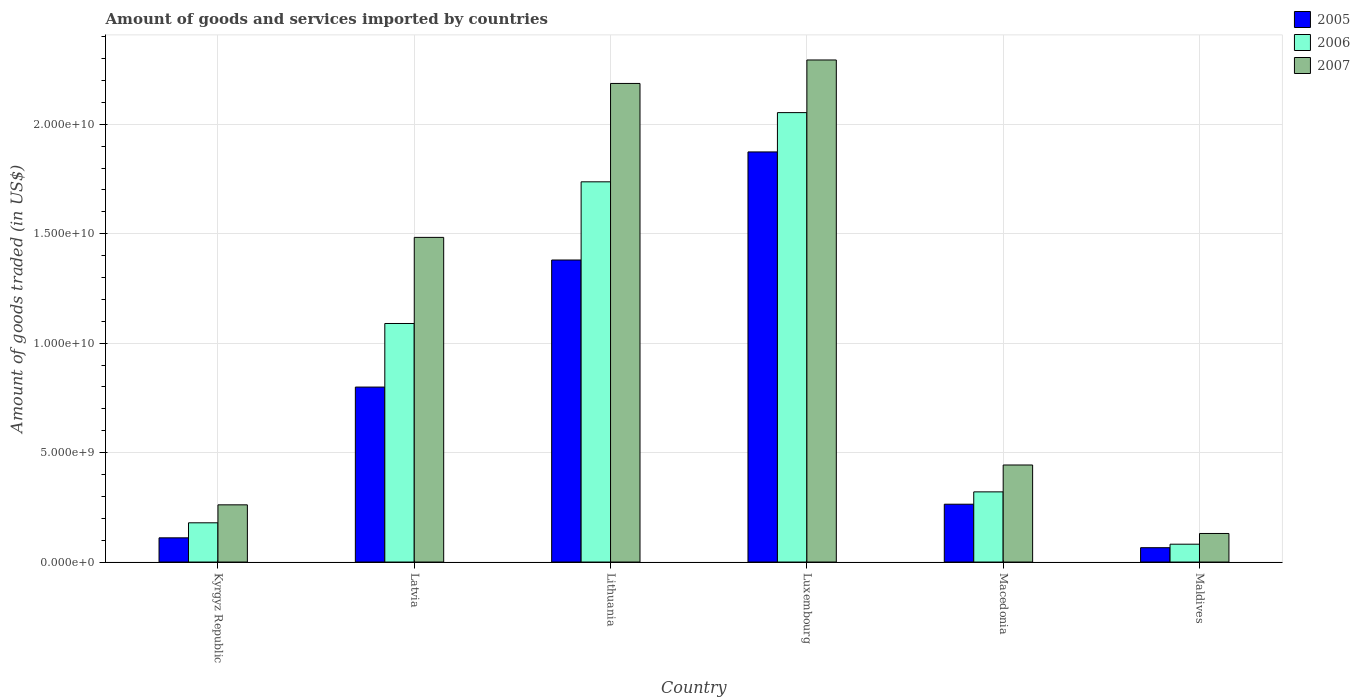How many different coloured bars are there?
Provide a succinct answer. 3. How many groups of bars are there?
Ensure brevity in your answer.  6. Are the number of bars per tick equal to the number of legend labels?
Offer a terse response. Yes. How many bars are there on the 5th tick from the right?
Provide a succinct answer. 3. What is the label of the 3rd group of bars from the left?
Make the answer very short. Lithuania. In how many cases, is the number of bars for a given country not equal to the number of legend labels?
Make the answer very short. 0. What is the total amount of goods and services imported in 2006 in Kyrgyz Republic?
Your answer should be very brief. 1.79e+09. Across all countries, what is the maximum total amount of goods and services imported in 2007?
Keep it short and to the point. 2.29e+1. Across all countries, what is the minimum total amount of goods and services imported in 2006?
Your answer should be compact. 8.15e+08. In which country was the total amount of goods and services imported in 2005 maximum?
Make the answer very short. Luxembourg. In which country was the total amount of goods and services imported in 2006 minimum?
Give a very brief answer. Maldives. What is the total total amount of goods and services imported in 2006 in the graph?
Offer a very short reply. 5.46e+1. What is the difference between the total amount of goods and services imported in 2006 in Macedonia and that in Maldives?
Your response must be concise. 2.39e+09. What is the difference between the total amount of goods and services imported in 2005 in Latvia and the total amount of goods and services imported in 2006 in Macedonia?
Provide a succinct answer. 4.79e+09. What is the average total amount of goods and services imported in 2007 per country?
Your response must be concise. 1.13e+1. What is the difference between the total amount of goods and services imported of/in 2006 and total amount of goods and services imported of/in 2007 in Kyrgyz Republic?
Provide a succinct answer. -8.21e+08. What is the ratio of the total amount of goods and services imported in 2006 in Latvia to that in Luxembourg?
Your answer should be compact. 0.53. What is the difference between the highest and the second highest total amount of goods and services imported in 2006?
Provide a short and direct response. 6.47e+09. What is the difference between the highest and the lowest total amount of goods and services imported in 2007?
Keep it short and to the point. 2.16e+1. In how many countries, is the total amount of goods and services imported in 2006 greater than the average total amount of goods and services imported in 2006 taken over all countries?
Your answer should be compact. 3. Is the sum of the total amount of goods and services imported in 2007 in Kyrgyz Republic and Latvia greater than the maximum total amount of goods and services imported in 2006 across all countries?
Provide a succinct answer. No. Is it the case that in every country, the sum of the total amount of goods and services imported in 2007 and total amount of goods and services imported in 2006 is greater than the total amount of goods and services imported in 2005?
Provide a succinct answer. Yes. How many bars are there?
Make the answer very short. 18. Are all the bars in the graph horizontal?
Provide a short and direct response. No. What is the difference between two consecutive major ticks on the Y-axis?
Provide a succinct answer. 5.00e+09. Are the values on the major ticks of Y-axis written in scientific E-notation?
Offer a terse response. Yes. Where does the legend appear in the graph?
Give a very brief answer. Top right. How many legend labels are there?
Provide a succinct answer. 3. How are the legend labels stacked?
Ensure brevity in your answer.  Vertical. What is the title of the graph?
Make the answer very short. Amount of goods and services imported by countries. Does "1976" appear as one of the legend labels in the graph?
Make the answer very short. No. What is the label or title of the Y-axis?
Your answer should be compact. Amount of goods traded (in US$). What is the Amount of goods traded (in US$) of 2005 in Kyrgyz Republic?
Your response must be concise. 1.11e+09. What is the Amount of goods traded (in US$) of 2006 in Kyrgyz Republic?
Provide a succinct answer. 1.79e+09. What is the Amount of goods traded (in US$) of 2007 in Kyrgyz Republic?
Offer a very short reply. 2.61e+09. What is the Amount of goods traded (in US$) of 2005 in Latvia?
Offer a terse response. 7.99e+09. What is the Amount of goods traded (in US$) of 2006 in Latvia?
Provide a succinct answer. 1.09e+1. What is the Amount of goods traded (in US$) of 2007 in Latvia?
Ensure brevity in your answer.  1.48e+1. What is the Amount of goods traded (in US$) of 2005 in Lithuania?
Offer a very short reply. 1.38e+1. What is the Amount of goods traded (in US$) in 2006 in Lithuania?
Provide a short and direct response. 1.74e+1. What is the Amount of goods traded (in US$) of 2007 in Lithuania?
Provide a succinct answer. 2.19e+1. What is the Amount of goods traded (in US$) in 2005 in Luxembourg?
Offer a terse response. 1.87e+1. What is the Amount of goods traded (in US$) of 2006 in Luxembourg?
Offer a terse response. 2.05e+1. What is the Amount of goods traded (in US$) of 2007 in Luxembourg?
Make the answer very short. 2.29e+1. What is the Amount of goods traded (in US$) in 2005 in Macedonia?
Your answer should be compact. 2.64e+09. What is the Amount of goods traded (in US$) in 2006 in Macedonia?
Ensure brevity in your answer.  3.21e+09. What is the Amount of goods traded (in US$) in 2007 in Macedonia?
Offer a terse response. 4.43e+09. What is the Amount of goods traded (in US$) in 2005 in Maldives?
Give a very brief answer. 6.55e+08. What is the Amount of goods traded (in US$) in 2006 in Maldives?
Keep it short and to the point. 8.15e+08. What is the Amount of goods traded (in US$) in 2007 in Maldives?
Your answer should be very brief. 1.30e+09. Across all countries, what is the maximum Amount of goods traded (in US$) in 2005?
Provide a short and direct response. 1.87e+1. Across all countries, what is the maximum Amount of goods traded (in US$) in 2006?
Your answer should be compact. 2.05e+1. Across all countries, what is the maximum Amount of goods traded (in US$) in 2007?
Provide a short and direct response. 2.29e+1. Across all countries, what is the minimum Amount of goods traded (in US$) of 2005?
Keep it short and to the point. 6.55e+08. Across all countries, what is the minimum Amount of goods traded (in US$) of 2006?
Give a very brief answer. 8.15e+08. Across all countries, what is the minimum Amount of goods traded (in US$) in 2007?
Provide a succinct answer. 1.30e+09. What is the total Amount of goods traded (in US$) in 2005 in the graph?
Provide a short and direct response. 4.49e+1. What is the total Amount of goods traded (in US$) in 2006 in the graph?
Your response must be concise. 5.46e+1. What is the total Amount of goods traded (in US$) of 2007 in the graph?
Your answer should be very brief. 6.80e+1. What is the difference between the Amount of goods traded (in US$) in 2005 in Kyrgyz Republic and that in Latvia?
Your answer should be very brief. -6.89e+09. What is the difference between the Amount of goods traded (in US$) in 2006 in Kyrgyz Republic and that in Latvia?
Your response must be concise. -9.11e+09. What is the difference between the Amount of goods traded (in US$) in 2007 in Kyrgyz Republic and that in Latvia?
Give a very brief answer. -1.22e+1. What is the difference between the Amount of goods traded (in US$) in 2005 in Kyrgyz Republic and that in Lithuania?
Provide a succinct answer. -1.27e+1. What is the difference between the Amount of goods traded (in US$) in 2006 in Kyrgyz Republic and that in Lithuania?
Keep it short and to the point. -1.56e+1. What is the difference between the Amount of goods traded (in US$) in 2007 in Kyrgyz Republic and that in Lithuania?
Your answer should be compact. -1.93e+1. What is the difference between the Amount of goods traded (in US$) of 2005 in Kyrgyz Republic and that in Luxembourg?
Your response must be concise. -1.76e+1. What is the difference between the Amount of goods traded (in US$) in 2006 in Kyrgyz Republic and that in Luxembourg?
Your response must be concise. -1.87e+1. What is the difference between the Amount of goods traded (in US$) of 2007 in Kyrgyz Republic and that in Luxembourg?
Make the answer very short. -2.03e+1. What is the difference between the Amount of goods traded (in US$) of 2005 in Kyrgyz Republic and that in Macedonia?
Ensure brevity in your answer.  -1.54e+09. What is the difference between the Amount of goods traded (in US$) in 2006 in Kyrgyz Republic and that in Macedonia?
Your answer should be very brief. -1.41e+09. What is the difference between the Amount of goods traded (in US$) of 2007 in Kyrgyz Republic and that in Macedonia?
Your response must be concise. -1.82e+09. What is the difference between the Amount of goods traded (in US$) of 2005 in Kyrgyz Republic and that in Maldives?
Keep it short and to the point. 4.50e+08. What is the difference between the Amount of goods traded (in US$) of 2006 in Kyrgyz Republic and that in Maldives?
Provide a short and direct response. 9.77e+08. What is the difference between the Amount of goods traded (in US$) of 2007 in Kyrgyz Republic and that in Maldives?
Give a very brief answer. 1.31e+09. What is the difference between the Amount of goods traded (in US$) in 2005 in Latvia and that in Lithuania?
Provide a short and direct response. -5.81e+09. What is the difference between the Amount of goods traded (in US$) of 2006 in Latvia and that in Lithuania?
Offer a very short reply. -6.47e+09. What is the difference between the Amount of goods traded (in US$) of 2007 in Latvia and that in Lithuania?
Give a very brief answer. -7.03e+09. What is the difference between the Amount of goods traded (in US$) in 2005 in Latvia and that in Luxembourg?
Offer a very short reply. -1.07e+1. What is the difference between the Amount of goods traded (in US$) of 2006 in Latvia and that in Luxembourg?
Give a very brief answer. -9.64e+09. What is the difference between the Amount of goods traded (in US$) in 2007 in Latvia and that in Luxembourg?
Ensure brevity in your answer.  -8.11e+09. What is the difference between the Amount of goods traded (in US$) of 2005 in Latvia and that in Macedonia?
Offer a very short reply. 5.35e+09. What is the difference between the Amount of goods traded (in US$) in 2006 in Latvia and that in Macedonia?
Keep it short and to the point. 7.69e+09. What is the difference between the Amount of goods traded (in US$) of 2007 in Latvia and that in Macedonia?
Your answer should be compact. 1.04e+1. What is the difference between the Amount of goods traded (in US$) in 2005 in Latvia and that in Maldives?
Offer a terse response. 7.34e+09. What is the difference between the Amount of goods traded (in US$) of 2006 in Latvia and that in Maldives?
Give a very brief answer. 1.01e+1. What is the difference between the Amount of goods traded (in US$) of 2007 in Latvia and that in Maldives?
Provide a short and direct response. 1.35e+1. What is the difference between the Amount of goods traded (in US$) of 2005 in Lithuania and that in Luxembourg?
Your answer should be very brief. -4.94e+09. What is the difference between the Amount of goods traded (in US$) of 2006 in Lithuania and that in Luxembourg?
Keep it short and to the point. -3.16e+09. What is the difference between the Amount of goods traded (in US$) of 2007 in Lithuania and that in Luxembourg?
Your answer should be compact. -1.07e+09. What is the difference between the Amount of goods traded (in US$) in 2005 in Lithuania and that in Macedonia?
Offer a terse response. 1.12e+1. What is the difference between the Amount of goods traded (in US$) of 2006 in Lithuania and that in Macedonia?
Provide a succinct answer. 1.42e+1. What is the difference between the Amount of goods traded (in US$) in 2007 in Lithuania and that in Macedonia?
Your response must be concise. 1.74e+1. What is the difference between the Amount of goods traded (in US$) of 2005 in Lithuania and that in Maldives?
Your answer should be very brief. 1.31e+1. What is the difference between the Amount of goods traded (in US$) of 2006 in Lithuania and that in Maldives?
Offer a terse response. 1.66e+1. What is the difference between the Amount of goods traded (in US$) in 2007 in Lithuania and that in Maldives?
Offer a very short reply. 2.06e+1. What is the difference between the Amount of goods traded (in US$) of 2005 in Luxembourg and that in Macedonia?
Make the answer very short. 1.61e+1. What is the difference between the Amount of goods traded (in US$) in 2006 in Luxembourg and that in Macedonia?
Keep it short and to the point. 1.73e+1. What is the difference between the Amount of goods traded (in US$) in 2007 in Luxembourg and that in Macedonia?
Provide a short and direct response. 1.85e+1. What is the difference between the Amount of goods traded (in US$) of 2005 in Luxembourg and that in Maldives?
Offer a very short reply. 1.81e+1. What is the difference between the Amount of goods traded (in US$) of 2006 in Luxembourg and that in Maldives?
Your answer should be compact. 1.97e+1. What is the difference between the Amount of goods traded (in US$) of 2007 in Luxembourg and that in Maldives?
Ensure brevity in your answer.  2.16e+1. What is the difference between the Amount of goods traded (in US$) in 2005 in Macedonia and that in Maldives?
Make the answer very short. 1.99e+09. What is the difference between the Amount of goods traded (in US$) of 2006 in Macedonia and that in Maldives?
Offer a terse response. 2.39e+09. What is the difference between the Amount of goods traded (in US$) of 2007 in Macedonia and that in Maldives?
Ensure brevity in your answer.  3.13e+09. What is the difference between the Amount of goods traded (in US$) of 2005 in Kyrgyz Republic and the Amount of goods traded (in US$) of 2006 in Latvia?
Your answer should be compact. -9.79e+09. What is the difference between the Amount of goods traded (in US$) in 2005 in Kyrgyz Republic and the Amount of goods traded (in US$) in 2007 in Latvia?
Make the answer very short. -1.37e+1. What is the difference between the Amount of goods traded (in US$) of 2006 in Kyrgyz Republic and the Amount of goods traded (in US$) of 2007 in Latvia?
Give a very brief answer. -1.30e+1. What is the difference between the Amount of goods traded (in US$) in 2005 in Kyrgyz Republic and the Amount of goods traded (in US$) in 2006 in Lithuania?
Provide a succinct answer. -1.63e+1. What is the difference between the Amount of goods traded (in US$) of 2005 in Kyrgyz Republic and the Amount of goods traded (in US$) of 2007 in Lithuania?
Ensure brevity in your answer.  -2.08e+1. What is the difference between the Amount of goods traded (in US$) in 2006 in Kyrgyz Republic and the Amount of goods traded (in US$) in 2007 in Lithuania?
Offer a very short reply. -2.01e+1. What is the difference between the Amount of goods traded (in US$) of 2005 in Kyrgyz Republic and the Amount of goods traded (in US$) of 2006 in Luxembourg?
Keep it short and to the point. -1.94e+1. What is the difference between the Amount of goods traded (in US$) in 2005 in Kyrgyz Republic and the Amount of goods traded (in US$) in 2007 in Luxembourg?
Keep it short and to the point. -2.18e+1. What is the difference between the Amount of goods traded (in US$) of 2006 in Kyrgyz Republic and the Amount of goods traded (in US$) of 2007 in Luxembourg?
Your response must be concise. -2.11e+1. What is the difference between the Amount of goods traded (in US$) of 2005 in Kyrgyz Republic and the Amount of goods traded (in US$) of 2006 in Macedonia?
Your answer should be very brief. -2.10e+09. What is the difference between the Amount of goods traded (in US$) of 2005 in Kyrgyz Republic and the Amount of goods traded (in US$) of 2007 in Macedonia?
Your answer should be compact. -3.33e+09. What is the difference between the Amount of goods traded (in US$) in 2006 in Kyrgyz Republic and the Amount of goods traded (in US$) in 2007 in Macedonia?
Give a very brief answer. -2.64e+09. What is the difference between the Amount of goods traded (in US$) of 2005 in Kyrgyz Republic and the Amount of goods traded (in US$) of 2006 in Maldives?
Provide a succinct answer. 2.90e+08. What is the difference between the Amount of goods traded (in US$) of 2005 in Kyrgyz Republic and the Amount of goods traded (in US$) of 2007 in Maldives?
Your answer should be very brief. -1.99e+08. What is the difference between the Amount of goods traded (in US$) of 2006 in Kyrgyz Republic and the Amount of goods traded (in US$) of 2007 in Maldives?
Your answer should be compact. 4.88e+08. What is the difference between the Amount of goods traded (in US$) in 2005 in Latvia and the Amount of goods traded (in US$) in 2006 in Lithuania?
Offer a terse response. -9.38e+09. What is the difference between the Amount of goods traded (in US$) in 2005 in Latvia and the Amount of goods traded (in US$) in 2007 in Lithuania?
Offer a very short reply. -1.39e+1. What is the difference between the Amount of goods traded (in US$) in 2006 in Latvia and the Amount of goods traded (in US$) in 2007 in Lithuania?
Offer a terse response. -1.10e+1. What is the difference between the Amount of goods traded (in US$) in 2005 in Latvia and the Amount of goods traded (in US$) in 2006 in Luxembourg?
Ensure brevity in your answer.  -1.25e+1. What is the difference between the Amount of goods traded (in US$) in 2005 in Latvia and the Amount of goods traded (in US$) in 2007 in Luxembourg?
Make the answer very short. -1.49e+1. What is the difference between the Amount of goods traded (in US$) in 2006 in Latvia and the Amount of goods traded (in US$) in 2007 in Luxembourg?
Make the answer very short. -1.20e+1. What is the difference between the Amount of goods traded (in US$) of 2005 in Latvia and the Amount of goods traded (in US$) of 2006 in Macedonia?
Your response must be concise. 4.79e+09. What is the difference between the Amount of goods traded (in US$) in 2005 in Latvia and the Amount of goods traded (in US$) in 2007 in Macedonia?
Provide a succinct answer. 3.56e+09. What is the difference between the Amount of goods traded (in US$) in 2006 in Latvia and the Amount of goods traded (in US$) in 2007 in Macedonia?
Offer a very short reply. 6.47e+09. What is the difference between the Amount of goods traded (in US$) of 2005 in Latvia and the Amount of goods traded (in US$) of 2006 in Maldives?
Give a very brief answer. 7.18e+09. What is the difference between the Amount of goods traded (in US$) of 2005 in Latvia and the Amount of goods traded (in US$) of 2007 in Maldives?
Offer a very short reply. 6.69e+09. What is the difference between the Amount of goods traded (in US$) of 2006 in Latvia and the Amount of goods traded (in US$) of 2007 in Maldives?
Provide a short and direct response. 9.59e+09. What is the difference between the Amount of goods traded (in US$) in 2005 in Lithuania and the Amount of goods traded (in US$) in 2006 in Luxembourg?
Offer a terse response. -6.74e+09. What is the difference between the Amount of goods traded (in US$) in 2005 in Lithuania and the Amount of goods traded (in US$) in 2007 in Luxembourg?
Provide a short and direct response. -9.14e+09. What is the difference between the Amount of goods traded (in US$) in 2006 in Lithuania and the Amount of goods traded (in US$) in 2007 in Luxembourg?
Provide a succinct answer. -5.57e+09. What is the difference between the Amount of goods traded (in US$) in 2005 in Lithuania and the Amount of goods traded (in US$) in 2006 in Macedonia?
Offer a very short reply. 1.06e+1. What is the difference between the Amount of goods traded (in US$) of 2005 in Lithuania and the Amount of goods traded (in US$) of 2007 in Macedonia?
Make the answer very short. 9.37e+09. What is the difference between the Amount of goods traded (in US$) in 2006 in Lithuania and the Amount of goods traded (in US$) in 2007 in Macedonia?
Your answer should be compact. 1.29e+1. What is the difference between the Amount of goods traded (in US$) in 2005 in Lithuania and the Amount of goods traded (in US$) in 2006 in Maldives?
Offer a very short reply. 1.30e+1. What is the difference between the Amount of goods traded (in US$) of 2005 in Lithuania and the Amount of goods traded (in US$) of 2007 in Maldives?
Give a very brief answer. 1.25e+1. What is the difference between the Amount of goods traded (in US$) in 2006 in Lithuania and the Amount of goods traded (in US$) in 2007 in Maldives?
Give a very brief answer. 1.61e+1. What is the difference between the Amount of goods traded (in US$) of 2005 in Luxembourg and the Amount of goods traded (in US$) of 2006 in Macedonia?
Ensure brevity in your answer.  1.55e+1. What is the difference between the Amount of goods traded (in US$) of 2005 in Luxembourg and the Amount of goods traded (in US$) of 2007 in Macedonia?
Offer a very short reply. 1.43e+1. What is the difference between the Amount of goods traded (in US$) in 2006 in Luxembourg and the Amount of goods traded (in US$) in 2007 in Macedonia?
Offer a terse response. 1.61e+1. What is the difference between the Amount of goods traded (in US$) in 2005 in Luxembourg and the Amount of goods traded (in US$) in 2006 in Maldives?
Make the answer very short. 1.79e+1. What is the difference between the Amount of goods traded (in US$) in 2005 in Luxembourg and the Amount of goods traded (in US$) in 2007 in Maldives?
Ensure brevity in your answer.  1.74e+1. What is the difference between the Amount of goods traded (in US$) of 2006 in Luxembourg and the Amount of goods traded (in US$) of 2007 in Maldives?
Provide a succinct answer. 1.92e+1. What is the difference between the Amount of goods traded (in US$) in 2005 in Macedonia and the Amount of goods traded (in US$) in 2006 in Maldives?
Offer a very short reply. 1.83e+09. What is the difference between the Amount of goods traded (in US$) in 2005 in Macedonia and the Amount of goods traded (in US$) in 2007 in Maldives?
Offer a terse response. 1.34e+09. What is the difference between the Amount of goods traded (in US$) in 2006 in Macedonia and the Amount of goods traded (in US$) in 2007 in Maldives?
Keep it short and to the point. 1.90e+09. What is the average Amount of goods traded (in US$) of 2005 per country?
Your answer should be compact. 7.49e+09. What is the average Amount of goods traded (in US$) in 2006 per country?
Provide a short and direct response. 9.10e+09. What is the average Amount of goods traded (in US$) in 2007 per country?
Make the answer very short. 1.13e+1. What is the difference between the Amount of goods traded (in US$) of 2005 and Amount of goods traded (in US$) of 2006 in Kyrgyz Republic?
Offer a terse response. -6.87e+08. What is the difference between the Amount of goods traded (in US$) in 2005 and Amount of goods traded (in US$) in 2007 in Kyrgyz Republic?
Ensure brevity in your answer.  -1.51e+09. What is the difference between the Amount of goods traded (in US$) in 2006 and Amount of goods traded (in US$) in 2007 in Kyrgyz Republic?
Keep it short and to the point. -8.21e+08. What is the difference between the Amount of goods traded (in US$) in 2005 and Amount of goods traded (in US$) in 2006 in Latvia?
Keep it short and to the point. -2.90e+09. What is the difference between the Amount of goods traded (in US$) in 2005 and Amount of goods traded (in US$) in 2007 in Latvia?
Your answer should be compact. -6.84e+09. What is the difference between the Amount of goods traded (in US$) in 2006 and Amount of goods traded (in US$) in 2007 in Latvia?
Your response must be concise. -3.93e+09. What is the difference between the Amount of goods traded (in US$) in 2005 and Amount of goods traded (in US$) in 2006 in Lithuania?
Your answer should be compact. -3.57e+09. What is the difference between the Amount of goods traded (in US$) of 2005 and Amount of goods traded (in US$) of 2007 in Lithuania?
Ensure brevity in your answer.  -8.07e+09. What is the difference between the Amount of goods traded (in US$) of 2006 and Amount of goods traded (in US$) of 2007 in Lithuania?
Offer a terse response. -4.50e+09. What is the difference between the Amount of goods traded (in US$) of 2005 and Amount of goods traded (in US$) of 2006 in Luxembourg?
Offer a terse response. -1.80e+09. What is the difference between the Amount of goods traded (in US$) in 2005 and Amount of goods traded (in US$) in 2007 in Luxembourg?
Provide a short and direct response. -4.20e+09. What is the difference between the Amount of goods traded (in US$) in 2006 and Amount of goods traded (in US$) in 2007 in Luxembourg?
Give a very brief answer. -2.40e+09. What is the difference between the Amount of goods traded (in US$) in 2005 and Amount of goods traded (in US$) in 2006 in Macedonia?
Provide a short and direct response. -5.64e+08. What is the difference between the Amount of goods traded (in US$) of 2005 and Amount of goods traded (in US$) of 2007 in Macedonia?
Provide a succinct answer. -1.79e+09. What is the difference between the Amount of goods traded (in US$) of 2006 and Amount of goods traded (in US$) of 2007 in Macedonia?
Give a very brief answer. -1.23e+09. What is the difference between the Amount of goods traded (in US$) in 2005 and Amount of goods traded (in US$) in 2006 in Maldives?
Give a very brief answer. -1.60e+08. What is the difference between the Amount of goods traded (in US$) of 2005 and Amount of goods traded (in US$) of 2007 in Maldives?
Your answer should be compact. -6.49e+08. What is the difference between the Amount of goods traded (in US$) in 2006 and Amount of goods traded (in US$) in 2007 in Maldives?
Your response must be concise. -4.89e+08. What is the ratio of the Amount of goods traded (in US$) in 2005 in Kyrgyz Republic to that in Latvia?
Provide a short and direct response. 0.14. What is the ratio of the Amount of goods traded (in US$) of 2006 in Kyrgyz Republic to that in Latvia?
Provide a succinct answer. 0.16. What is the ratio of the Amount of goods traded (in US$) in 2007 in Kyrgyz Republic to that in Latvia?
Provide a short and direct response. 0.18. What is the ratio of the Amount of goods traded (in US$) in 2005 in Kyrgyz Republic to that in Lithuania?
Ensure brevity in your answer.  0.08. What is the ratio of the Amount of goods traded (in US$) of 2006 in Kyrgyz Republic to that in Lithuania?
Provide a succinct answer. 0.1. What is the ratio of the Amount of goods traded (in US$) of 2007 in Kyrgyz Republic to that in Lithuania?
Provide a succinct answer. 0.12. What is the ratio of the Amount of goods traded (in US$) of 2005 in Kyrgyz Republic to that in Luxembourg?
Give a very brief answer. 0.06. What is the ratio of the Amount of goods traded (in US$) of 2006 in Kyrgyz Republic to that in Luxembourg?
Offer a very short reply. 0.09. What is the ratio of the Amount of goods traded (in US$) of 2007 in Kyrgyz Republic to that in Luxembourg?
Your answer should be very brief. 0.11. What is the ratio of the Amount of goods traded (in US$) in 2005 in Kyrgyz Republic to that in Macedonia?
Give a very brief answer. 0.42. What is the ratio of the Amount of goods traded (in US$) in 2006 in Kyrgyz Republic to that in Macedonia?
Your answer should be compact. 0.56. What is the ratio of the Amount of goods traded (in US$) of 2007 in Kyrgyz Republic to that in Macedonia?
Ensure brevity in your answer.  0.59. What is the ratio of the Amount of goods traded (in US$) in 2005 in Kyrgyz Republic to that in Maldives?
Provide a succinct answer. 1.69. What is the ratio of the Amount of goods traded (in US$) of 2006 in Kyrgyz Republic to that in Maldives?
Your answer should be very brief. 2.2. What is the ratio of the Amount of goods traded (in US$) of 2007 in Kyrgyz Republic to that in Maldives?
Offer a terse response. 2. What is the ratio of the Amount of goods traded (in US$) in 2005 in Latvia to that in Lithuania?
Give a very brief answer. 0.58. What is the ratio of the Amount of goods traded (in US$) in 2006 in Latvia to that in Lithuania?
Make the answer very short. 0.63. What is the ratio of the Amount of goods traded (in US$) in 2007 in Latvia to that in Lithuania?
Make the answer very short. 0.68. What is the ratio of the Amount of goods traded (in US$) of 2005 in Latvia to that in Luxembourg?
Provide a succinct answer. 0.43. What is the ratio of the Amount of goods traded (in US$) of 2006 in Latvia to that in Luxembourg?
Your answer should be compact. 0.53. What is the ratio of the Amount of goods traded (in US$) in 2007 in Latvia to that in Luxembourg?
Provide a succinct answer. 0.65. What is the ratio of the Amount of goods traded (in US$) in 2005 in Latvia to that in Macedonia?
Provide a short and direct response. 3.03. What is the ratio of the Amount of goods traded (in US$) in 2006 in Latvia to that in Macedonia?
Provide a succinct answer. 3.4. What is the ratio of the Amount of goods traded (in US$) of 2007 in Latvia to that in Macedonia?
Make the answer very short. 3.35. What is the ratio of the Amount of goods traded (in US$) of 2005 in Latvia to that in Maldives?
Your response must be concise. 12.2. What is the ratio of the Amount of goods traded (in US$) of 2006 in Latvia to that in Maldives?
Your answer should be compact. 13.37. What is the ratio of the Amount of goods traded (in US$) in 2007 in Latvia to that in Maldives?
Ensure brevity in your answer.  11.37. What is the ratio of the Amount of goods traded (in US$) of 2005 in Lithuania to that in Luxembourg?
Make the answer very short. 0.74. What is the ratio of the Amount of goods traded (in US$) in 2006 in Lithuania to that in Luxembourg?
Provide a short and direct response. 0.85. What is the ratio of the Amount of goods traded (in US$) in 2007 in Lithuania to that in Luxembourg?
Make the answer very short. 0.95. What is the ratio of the Amount of goods traded (in US$) in 2005 in Lithuania to that in Macedonia?
Offer a very short reply. 5.22. What is the ratio of the Amount of goods traded (in US$) of 2006 in Lithuania to that in Macedonia?
Offer a very short reply. 5.42. What is the ratio of the Amount of goods traded (in US$) of 2007 in Lithuania to that in Macedonia?
Provide a short and direct response. 4.93. What is the ratio of the Amount of goods traded (in US$) in 2005 in Lithuania to that in Maldives?
Provide a short and direct response. 21.05. What is the ratio of the Amount of goods traded (in US$) of 2006 in Lithuania to that in Maldives?
Your response must be concise. 21.31. What is the ratio of the Amount of goods traded (in US$) of 2007 in Lithuania to that in Maldives?
Offer a terse response. 16.76. What is the ratio of the Amount of goods traded (in US$) in 2005 in Luxembourg to that in Macedonia?
Keep it short and to the point. 7.09. What is the ratio of the Amount of goods traded (in US$) of 2006 in Luxembourg to that in Macedonia?
Ensure brevity in your answer.  6.41. What is the ratio of the Amount of goods traded (in US$) of 2007 in Luxembourg to that in Macedonia?
Give a very brief answer. 5.17. What is the ratio of the Amount of goods traded (in US$) of 2005 in Luxembourg to that in Maldives?
Give a very brief answer. 28.59. What is the ratio of the Amount of goods traded (in US$) in 2006 in Luxembourg to that in Maldives?
Ensure brevity in your answer.  25.19. What is the ratio of the Amount of goods traded (in US$) of 2007 in Luxembourg to that in Maldives?
Ensure brevity in your answer.  17.58. What is the ratio of the Amount of goods traded (in US$) in 2005 in Macedonia to that in Maldives?
Offer a terse response. 4.03. What is the ratio of the Amount of goods traded (in US$) of 2006 in Macedonia to that in Maldives?
Ensure brevity in your answer.  3.93. What is the ratio of the Amount of goods traded (in US$) of 2007 in Macedonia to that in Maldives?
Make the answer very short. 3.4. What is the difference between the highest and the second highest Amount of goods traded (in US$) in 2005?
Give a very brief answer. 4.94e+09. What is the difference between the highest and the second highest Amount of goods traded (in US$) in 2006?
Ensure brevity in your answer.  3.16e+09. What is the difference between the highest and the second highest Amount of goods traded (in US$) in 2007?
Ensure brevity in your answer.  1.07e+09. What is the difference between the highest and the lowest Amount of goods traded (in US$) of 2005?
Your answer should be very brief. 1.81e+1. What is the difference between the highest and the lowest Amount of goods traded (in US$) in 2006?
Your answer should be very brief. 1.97e+1. What is the difference between the highest and the lowest Amount of goods traded (in US$) in 2007?
Provide a short and direct response. 2.16e+1. 